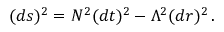<formula> <loc_0><loc_0><loc_500><loc_500>( d s ) ^ { 2 } = N ^ { 2 } ( d t ) ^ { 2 } - \Lambda ^ { 2 } ( d r ) ^ { 2 } \, .</formula> 